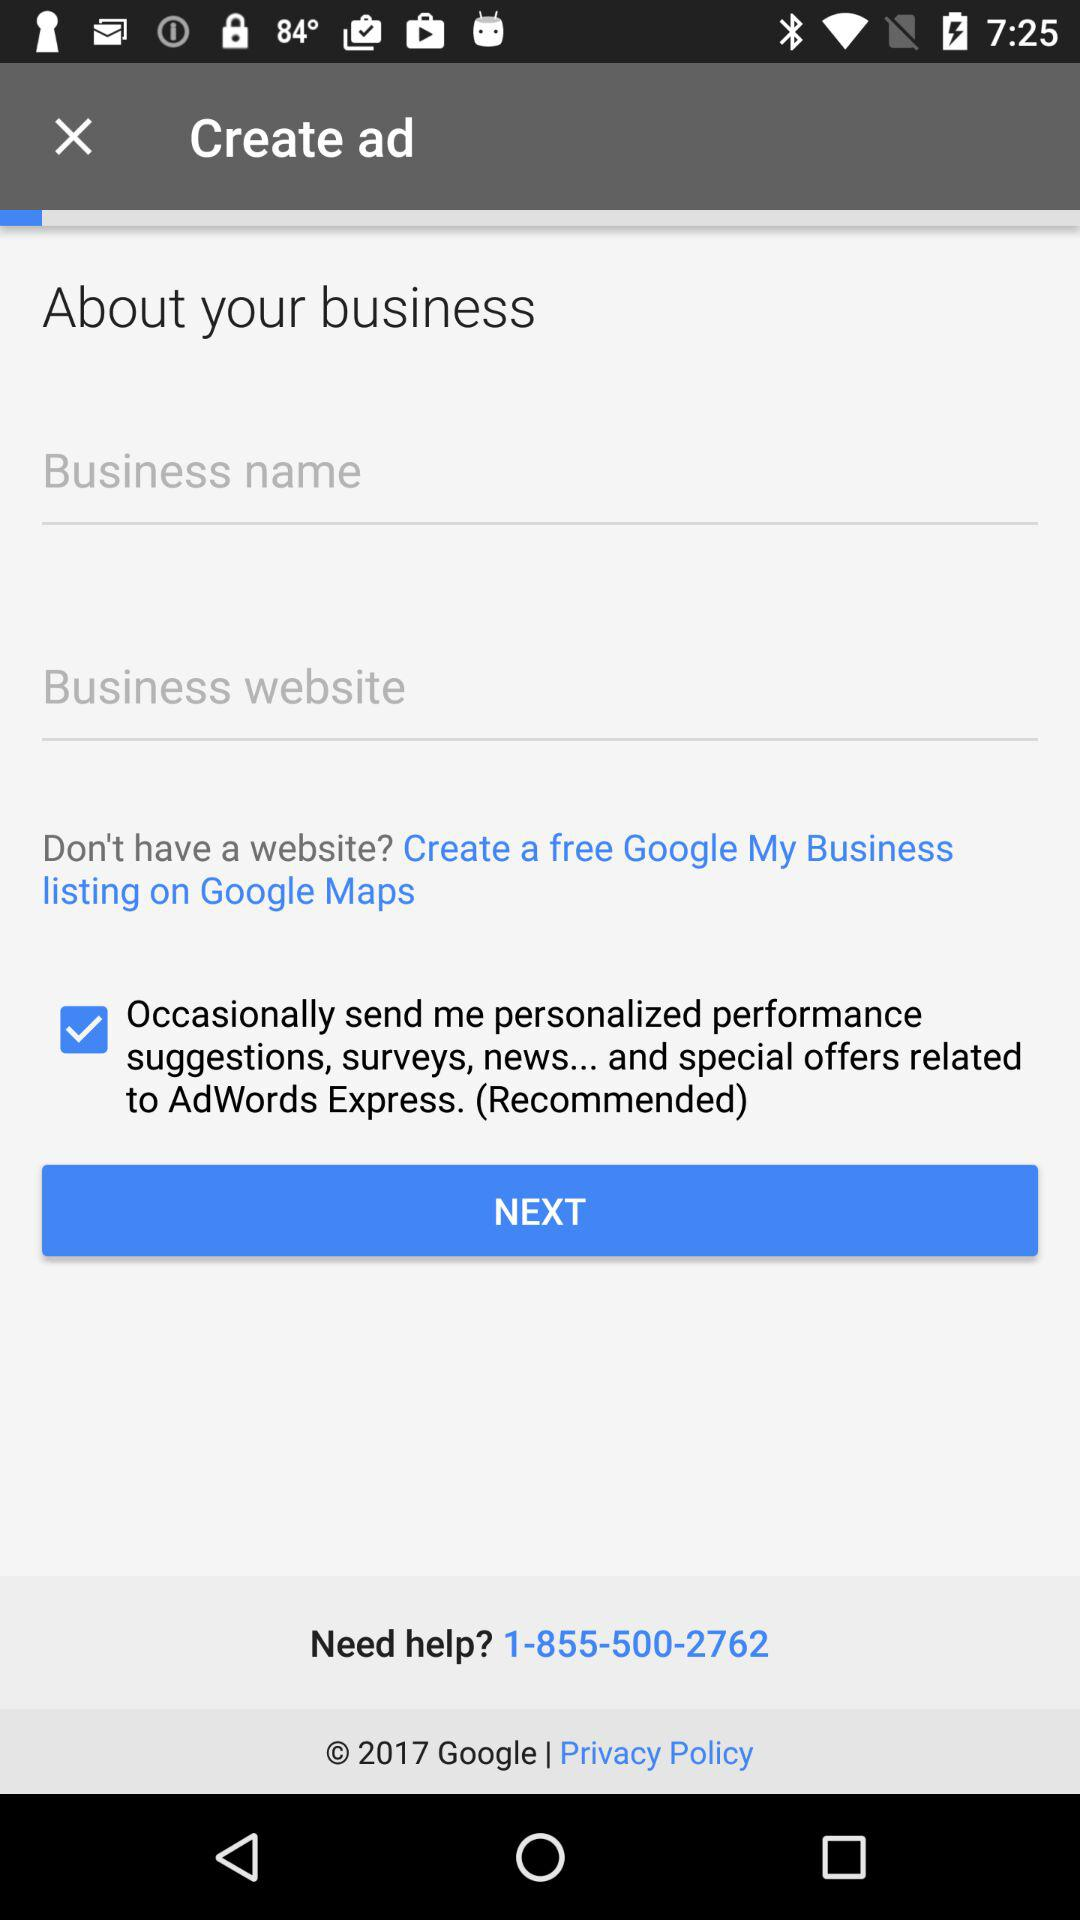How many input fields are there for the business information?
Answer the question using a single word or phrase. 2 